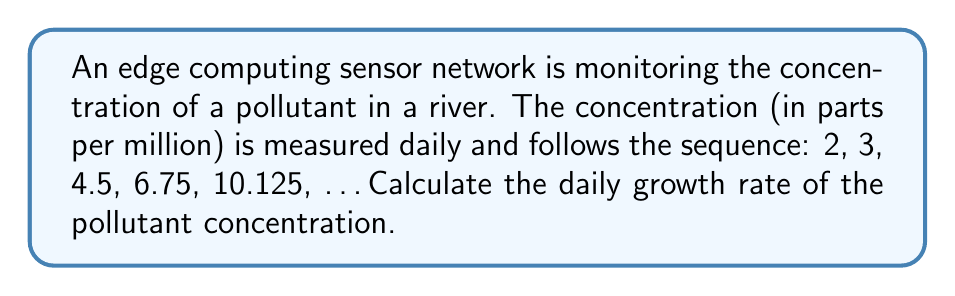Show me your answer to this math problem. To calculate the daily growth rate, we need to follow these steps:

1. Identify the pattern in the sequence:
   Each term is multiplied by a constant factor to get the next term.

2. Calculate the ratio between consecutive terms:
   $\frac{3}{2} = 1.5$
   $\frac{4.5}{3} = 1.5$
   $\frac{6.75}{4.5} = 1.5$
   $\frac{10.125}{6.75} = 1.5$

3. The constant factor is 1.5, which means the concentration is increasing by 50% each day.

4. To express this as a growth rate, we subtract 1 from the factor and convert to a percentage:
   Growth rate = (1.5 - 1) × 100% = 0.5 × 100% = 50%

Therefore, the daily growth rate of the pollutant concentration is 50%.
Answer: 50% 